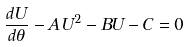Convert formula to latex. <formula><loc_0><loc_0><loc_500><loc_500>\frac { d U } { d \theta } - A U ^ { 2 } - B U - C = 0</formula> 